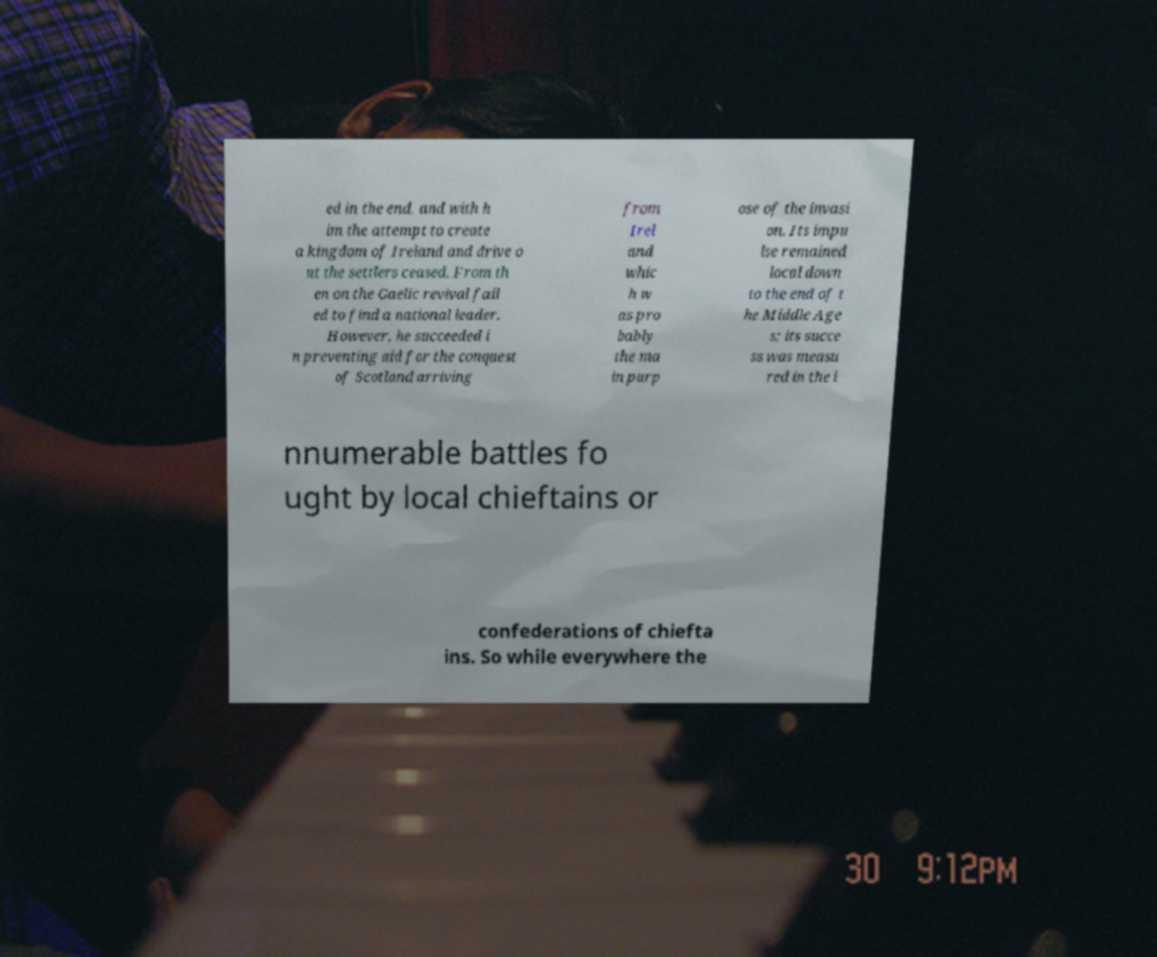Can you read and provide the text displayed in the image?This photo seems to have some interesting text. Can you extract and type it out for me? ed in the end, and with h im the attempt to create a kingdom of Ireland and drive o ut the settlers ceased. From th en on the Gaelic revival fail ed to find a national leader. However, he succeeded i n preventing aid for the conquest of Scotland arriving from Irel and whic h w as pro bably the ma in purp ose of the invasi on. Its impu lse remained local down to the end of t he Middle Age s; its succe ss was measu red in the i nnumerable battles fo ught by local chieftains or confederations of chiefta ins. So while everywhere the 